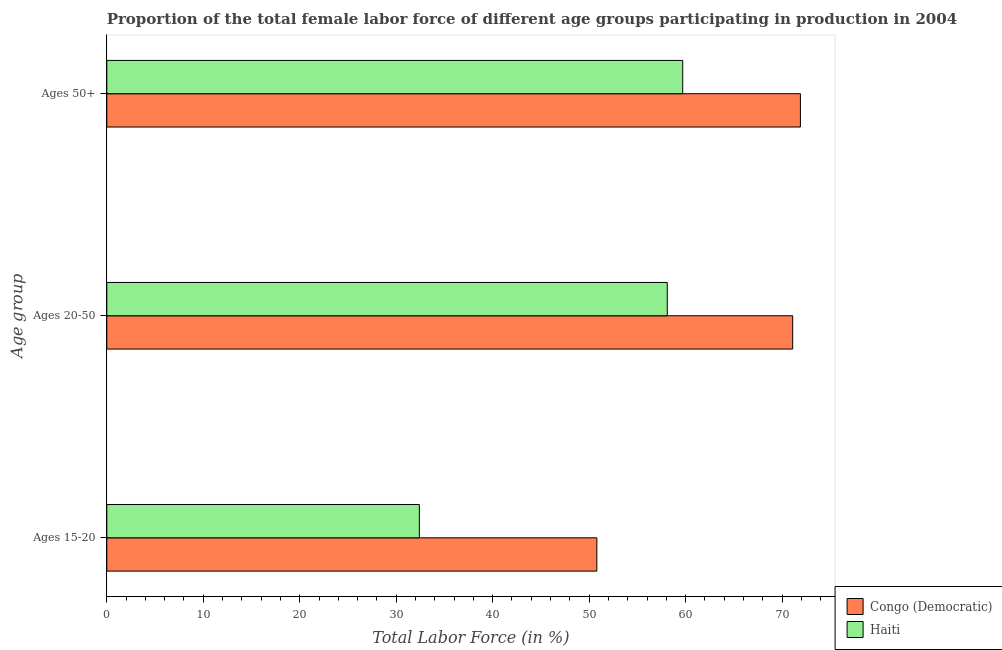How many different coloured bars are there?
Your answer should be compact. 2. How many groups of bars are there?
Offer a very short reply. 3. Are the number of bars per tick equal to the number of legend labels?
Make the answer very short. Yes. How many bars are there on the 1st tick from the top?
Make the answer very short. 2. What is the label of the 2nd group of bars from the top?
Keep it short and to the point. Ages 20-50. What is the percentage of female labor force within the age group 15-20 in Congo (Democratic)?
Your response must be concise. 50.8. Across all countries, what is the maximum percentage of female labor force within the age group 20-50?
Ensure brevity in your answer.  71.1. Across all countries, what is the minimum percentage of female labor force within the age group 20-50?
Offer a terse response. 58.1. In which country was the percentage of female labor force above age 50 maximum?
Ensure brevity in your answer.  Congo (Democratic). In which country was the percentage of female labor force within the age group 20-50 minimum?
Offer a terse response. Haiti. What is the total percentage of female labor force above age 50 in the graph?
Your response must be concise. 131.6. What is the difference between the percentage of female labor force within the age group 15-20 in Haiti and that in Congo (Democratic)?
Provide a succinct answer. -18.4. What is the difference between the percentage of female labor force above age 50 in Haiti and the percentage of female labor force within the age group 15-20 in Congo (Democratic)?
Your answer should be compact. 8.9. What is the average percentage of female labor force above age 50 per country?
Provide a short and direct response. 65.8. What is the difference between the percentage of female labor force within the age group 20-50 and percentage of female labor force within the age group 15-20 in Congo (Democratic)?
Provide a short and direct response. 20.3. What is the ratio of the percentage of female labor force above age 50 in Congo (Democratic) to that in Haiti?
Ensure brevity in your answer.  1.2. Is the percentage of female labor force within the age group 15-20 in Congo (Democratic) less than that in Haiti?
Your response must be concise. No. Is the difference between the percentage of female labor force above age 50 in Congo (Democratic) and Haiti greater than the difference between the percentage of female labor force within the age group 20-50 in Congo (Democratic) and Haiti?
Keep it short and to the point. No. What is the difference between the highest and the second highest percentage of female labor force above age 50?
Keep it short and to the point. 12.2. What is the difference between the highest and the lowest percentage of female labor force within the age group 20-50?
Offer a terse response. 13. Is the sum of the percentage of female labor force within the age group 15-20 in Congo (Democratic) and Haiti greater than the maximum percentage of female labor force above age 50 across all countries?
Keep it short and to the point. Yes. What does the 2nd bar from the top in Ages 20-50 represents?
Provide a succinct answer. Congo (Democratic). What does the 1st bar from the bottom in Ages 50+ represents?
Make the answer very short. Congo (Democratic). How many countries are there in the graph?
Provide a succinct answer. 2. Are the values on the major ticks of X-axis written in scientific E-notation?
Make the answer very short. No. Does the graph contain any zero values?
Keep it short and to the point. No. How many legend labels are there?
Offer a very short reply. 2. How are the legend labels stacked?
Give a very brief answer. Vertical. What is the title of the graph?
Offer a very short reply. Proportion of the total female labor force of different age groups participating in production in 2004. Does "French Polynesia" appear as one of the legend labels in the graph?
Make the answer very short. No. What is the label or title of the X-axis?
Give a very brief answer. Total Labor Force (in %). What is the label or title of the Y-axis?
Ensure brevity in your answer.  Age group. What is the Total Labor Force (in %) of Congo (Democratic) in Ages 15-20?
Make the answer very short. 50.8. What is the Total Labor Force (in %) in Haiti in Ages 15-20?
Ensure brevity in your answer.  32.4. What is the Total Labor Force (in %) in Congo (Democratic) in Ages 20-50?
Give a very brief answer. 71.1. What is the Total Labor Force (in %) of Haiti in Ages 20-50?
Ensure brevity in your answer.  58.1. What is the Total Labor Force (in %) in Congo (Democratic) in Ages 50+?
Give a very brief answer. 71.9. What is the Total Labor Force (in %) of Haiti in Ages 50+?
Your answer should be compact. 59.7. Across all Age group, what is the maximum Total Labor Force (in %) of Congo (Democratic)?
Keep it short and to the point. 71.9. Across all Age group, what is the maximum Total Labor Force (in %) of Haiti?
Provide a short and direct response. 59.7. Across all Age group, what is the minimum Total Labor Force (in %) of Congo (Democratic)?
Your response must be concise. 50.8. Across all Age group, what is the minimum Total Labor Force (in %) of Haiti?
Your answer should be very brief. 32.4. What is the total Total Labor Force (in %) in Congo (Democratic) in the graph?
Offer a very short reply. 193.8. What is the total Total Labor Force (in %) of Haiti in the graph?
Offer a very short reply. 150.2. What is the difference between the Total Labor Force (in %) in Congo (Democratic) in Ages 15-20 and that in Ages 20-50?
Keep it short and to the point. -20.3. What is the difference between the Total Labor Force (in %) in Haiti in Ages 15-20 and that in Ages 20-50?
Provide a succinct answer. -25.7. What is the difference between the Total Labor Force (in %) in Congo (Democratic) in Ages 15-20 and that in Ages 50+?
Your response must be concise. -21.1. What is the difference between the Total Labor Force (in %) of Haiti in Ages 15-20 and that in Ages 50+?
Keep it short and to the point. -27.3. What is the difference between the Total Labor Force (in %) of Congo (Democratic) in Ages 20-50 and that in Ages 50+?
Make the answer very short. -0.8. What is the difference between the Total Labor Force (in %) of Haiti in Ages 20-50 and that in Ages 50+?
Offer a very short reply. -1.6. What is the difference between the Total Labor Force (in %) in Congo (Democratic) in Ages 15-20 and the Total Labor Force (in %) in Haiti in Ages 20-50?
Your answer should be very brief. -7.3. What is the average Total Labor Force (in %) in Congo (Democratic) per Age group?
Keep it short and to the point. 64.6. What is the average Total Labor Force (in %) in Haiti per Age group?
Provide a succinct answer. 50.07. What is the difference between the Total Labor Force (in %) of Congo (Democratic) and Total Labor Force (in %) of Haiti in Ages 20-50?
Your answer should be very brief. 13. What is the difference between the Total Labor Force (in %) of Congo (Democratic) and Total Labor Force (in %) of Haiti in Ages 50+?
Provide a short and direct response. 12.2. What is the ratio of the Total Labor Force (in %) in Congo (Democratic) in Ages 15-20 to that in Ages 20-50?
Offer a terse response. 0.71. What is the ratio of the Total Labor Force (in %) in Haiti in Ages 15-20 to that in Ages 20-50?
Offer a terse response. 0.56. What is the ratio of the Total Labor Force (in %) in Congo (Democratic) in Ages 15-20 to that in Ages 50+?
Offer a very short reply. 0.71. What is the ratio of the Total Labor Force (in %) in Haiti in Ages 15-20 to that in Ages 50+?
Give a very brief answer. 0.54. What is the ratio of the Total Labor Force (in %) in Congo (Democratic) in Ages 20-50 to that in Ages 50+?
Give a very brief answer. 0.99. What is the ratio of the Total Labor Force (in %) of Haiti in Ages 20-50 to that in Ages 50+?
Your answer should be very brief. 0.97. What is the difference between the highest and the second highest Total Labor Force (in %) in Haiti?
Ensure brevity in your answer.  1.6. What is the difference between the highest and the lowest Total Labor Force (in %) in Congo (Democratic)?
Offer a very short reply. 21.1. What is the difference between the highest and the lowest Total Labor Force (in %) in Haiti?
Provide a succinct answer. 27.3. 